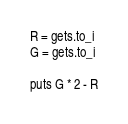Convert code to text. <code><loc_0><loc_0><loc_500><loc_500><_Ruby_>R = gets.to_i
G = gets.to_i

puts G * 2 - R</code> 